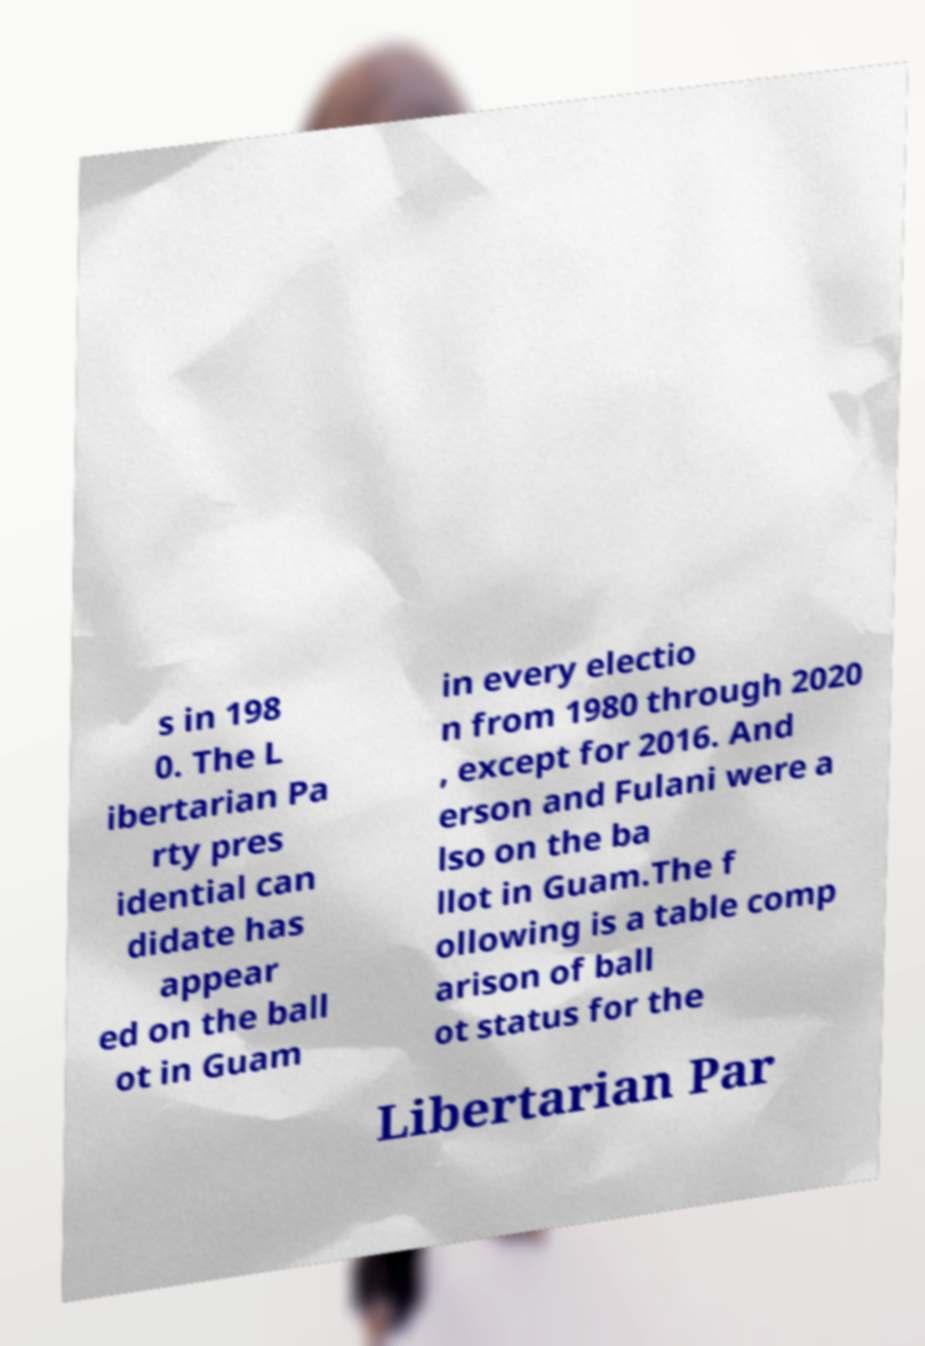I need the written content from this picture converted into text. Can you do that? s in 198 0. The L ibertarian Pa rty pres idential can didate has appear ed on the ball ot in Guam in every electio n from 1980 through 2020 , except for 2016. And erson and Fulani were a lso on the ba llot in Guam.The f ollowing is a table comp arison of ball ot status for the Libertarian Par 